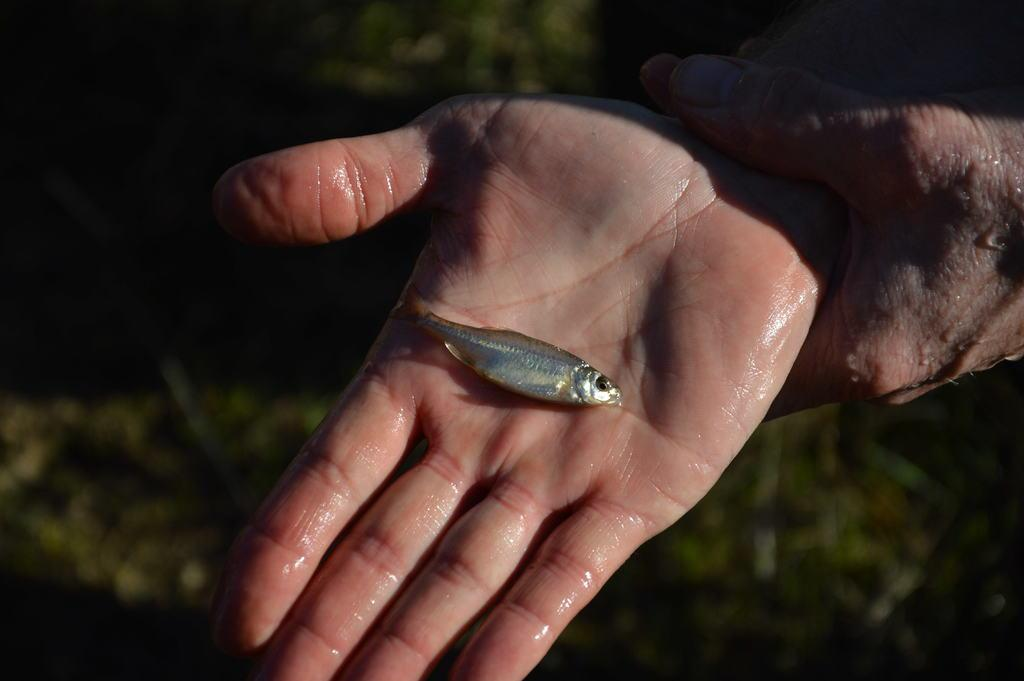What type of animal is in the image? There is a small fish in the image. Where is the fish located? The fish is on a person's hand. Can you describe the background of the image? The background of the image is blurry. What reaction can be seen on the ducks' faces in the image? There are no ducks present in the image, so it is not possible to determine their reactions. 